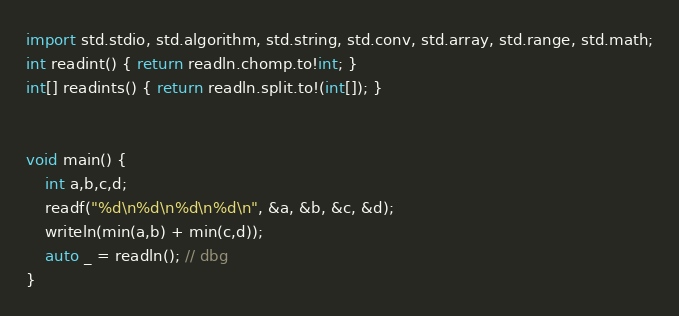Convert code to text. <code><loc_0><loc_0><loc_500><loc_500><_D_>import std.stdio, std.algorithm, std.string, std.conv, std.array, std.range, std.math;
int readint() { return readln.chomp.to!int; }
int[] readints() { return readln.split.to!(int[]); }


void main() {
    int a,b,c,d;
    readf("%d\n%d\n%d\n%d\n", &a, &b, &c, &d);
    writeln(min(a,b) + min(c,d));
    auto _ = readln(); // dbg
}</code> 